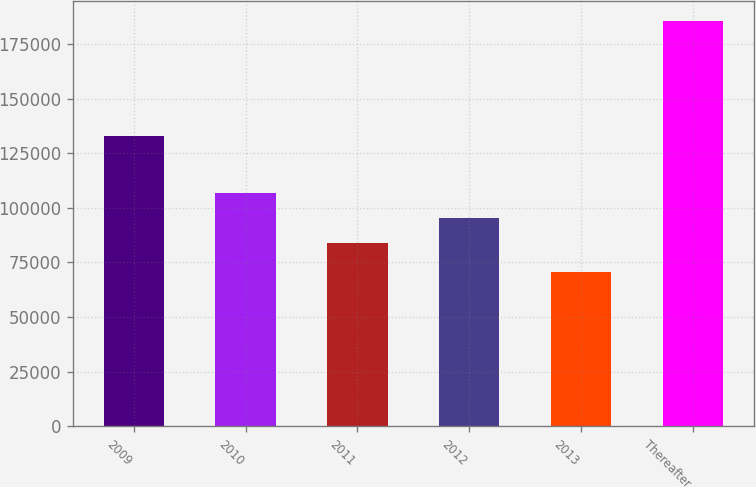Convert chart to OTSL. <chart><loc_0><loc_0><loc_500><loc_500><bar_chart><fcel>2009<fcel>2010<fcel>2011<fcel>2012<fcel>2013<fcel>Thereafter<nl><fcel>132841<fcel>106893<fcel>83927<fcel>95410<fcel>70599<fcel>185429<nl></chart> 